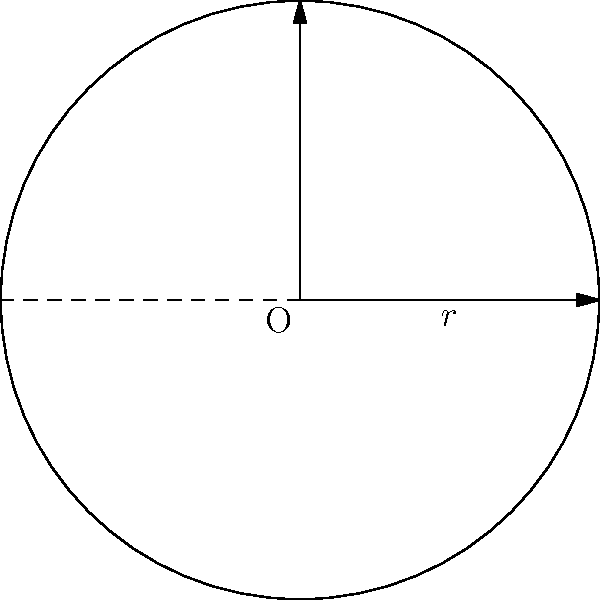A circular radar system has a radius of 10 km. Calculate the total area that can be covered by this radar system. Round your answer to the nearest square kilometer. To solve this problem, we need to follow these steps:

1. Recall the formula for the area of a circle:
   $$A = \pi r^2$$
   where $A$ is the area and $r$ is the radius.

2. We are given that the radius $r = 10$ km.

3. Substitute the value into the formula:
   $$A = \pi (10 \text{ km})^2$$

4. Simplify:
   $$A = 100\pi \text{ km}^2$$

5. Calculate the value (use 3.14159 for $\pi$):
   $$A = 100 \times 3.14159 \text{ km}^2 = 314.159 \text{ km}^2$$

6. Round to the nearest square kilometer:
   $$A \approx 314 \text{ km}^2$$

This calculation gives us the total area that can be covered by the radar system.
Answer: 314 km² 